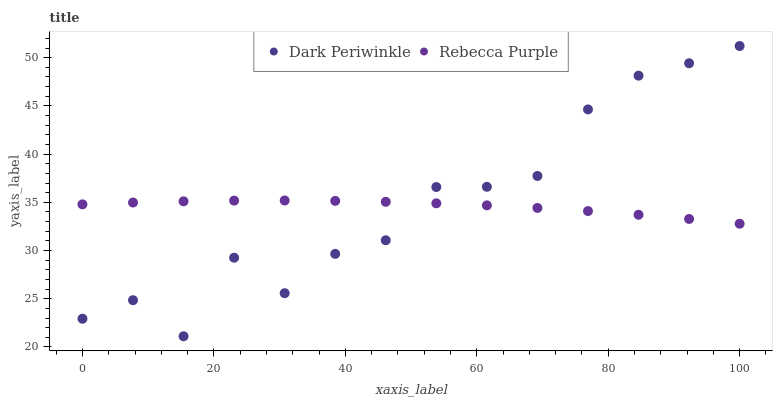Does Rebecca Purple have the minimum area under the curve?
Answer yes or no. Yes. Does Dark Periwinkle have the maximum area under the curve?
Answer yes or no. Yes. Does Rebecca Purple have the maximum area under the curve?
Answer yes or no. No. Is Rebecca Purple the smoothest?
Answer yes or no. Yes. Is Dark Periwinkle the roughest?
Answer yes or no. Yes. Is Rebecca Purple the roughest?
Answer yes or no. No. Does Dark Periwinkle have the lowest value?
Answer yes or no. Yes. Does Rebecca Purple have the lowest value?
Answer yes or no. No. Does Dark Periwinkle have the highest value?
Answer yes or no. Yes. Does Rebecca Purple have the highest value?
Answer yes or no. No. Does Dark Periwinkle intersect Rebecca Purple?
Answer yes or no. Yes. Is Dark Periwinkle less than Rebecca Purple?
Answer yes or no. No. Is Dark Periwinkle greater than Rebecca Purple?
Answer yes or no. No. 